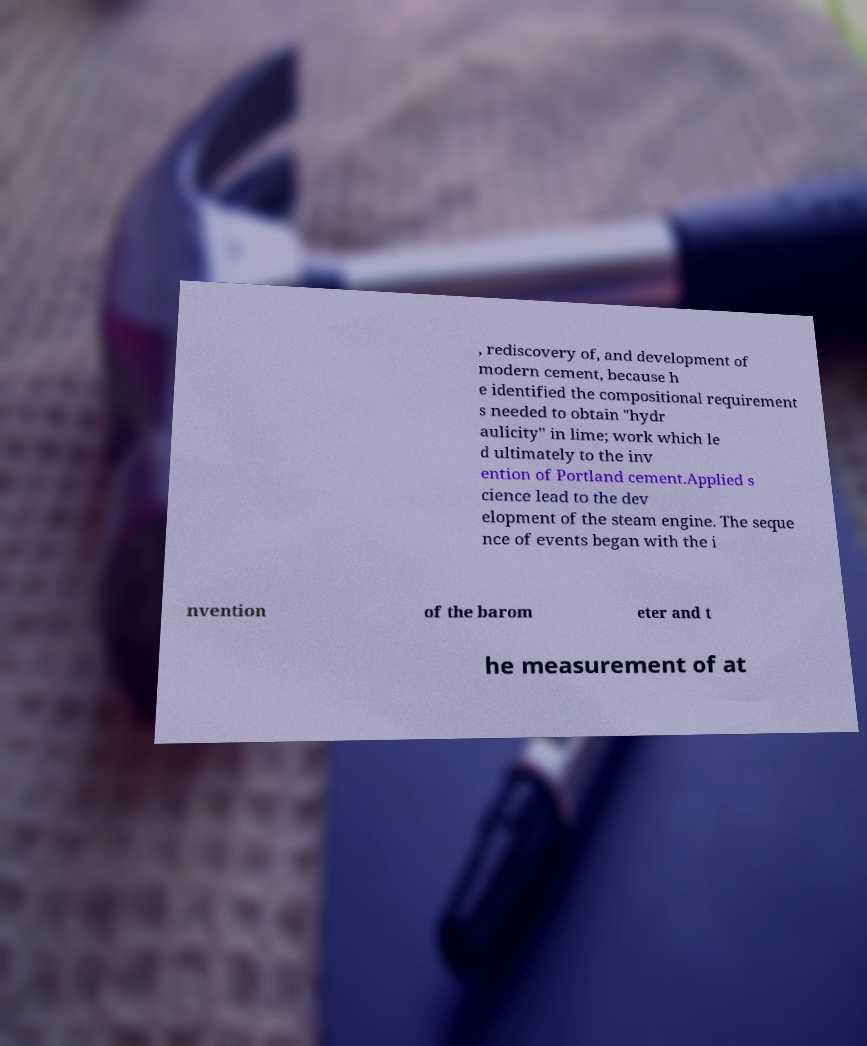Please read and relay the text visible in this image. What does it say? , rediscovery of, and development of modern cement, because h e identified the compositional requirement s needed to obtain "hydr aulicity" in lime; work which le d ultimately to the inv ention of Portland cement.Applied s cience lead to the dev elopment of the steam engine. The seque nce of events began with the i nvention of the barom eter and t he measurement of at 